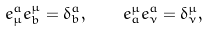<formula> <loc_0><loc_0><loc_500><loc_500>e ^ { a } _ { \mu } e ^ { \mu } _ { b } = \delta ^ { a } _ { b } , \quad e ^ { \mu } _ { a } e ^ { a } _ { \nu } = \delta ^ { \mu } _ { \nu } ,</formula> 